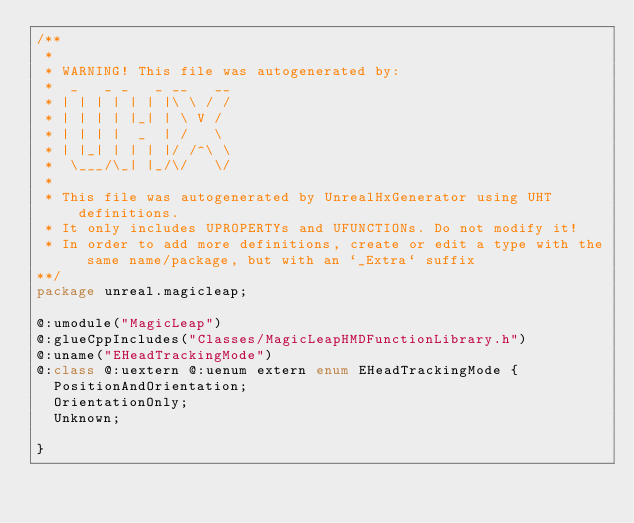<code> <loc_0><loc_0><loc_500><loc_500><_Haxe_>/**
 * 
 * WARNING! This file was autogenerated by: 
 *  _   _ _   _ __   __ 
 * | | | | | | |\ \ / / 
 * | | | | |_| | \ V /  
 * | | | |  _  | /   \  
 * | |_| | | | |/ /^\ \ 
 *  \___/\_| |_/\/   \/ 
 * 
 * This file was autogenerated by UnrealHxGenerator using UHT definitions.
 * It only includes UPROPERTYs and UFUNCTIONs. Do not modify it!
 * In order to add more definitions, create or edit a type with the same name/package, but with an `_Extra` suffix
**/
package unreal.magicleap;

@:umodule("MagicLeap")
@:glueCppIncludes("Classes/MagicLeapHMDFunctionLibrary.h")
@:uname("EHeadTrackingMode")
@:class @:uextern @:uenum extern enum EHeadTrackingMode {
  PositionAndOrientation;
  OrientationOnly;
  Unknown;
  
}
</code> 